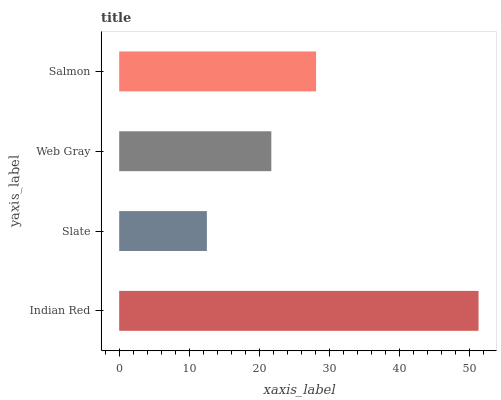Is Slate the minimum?
Answer yes or no. Yes. Is Indian Red the maximum?
Answer yes or no. Yes. Is Web Gray the minimum?
Answer yes or no. No. Is Web Gray the maximum?
Answer yes or no. No. Is Web Gray greater than Slate?
Answer yes or no. Yes. Is Slate less than Web Gray?
Answer yes or no. Yes. Is Slate greater than Web Gray?
Answer yes or no. No. Is Web Gray less than Slate?
Answer yes or no. No. Is Salmon the high median?
Answer yes or no. Yes. Is Web Gray the low median?
Answer yes or no. Yes. Is Slate the high median?
Answer yes or no. No. Is Slate the low median?
Answer yes or no. No. 